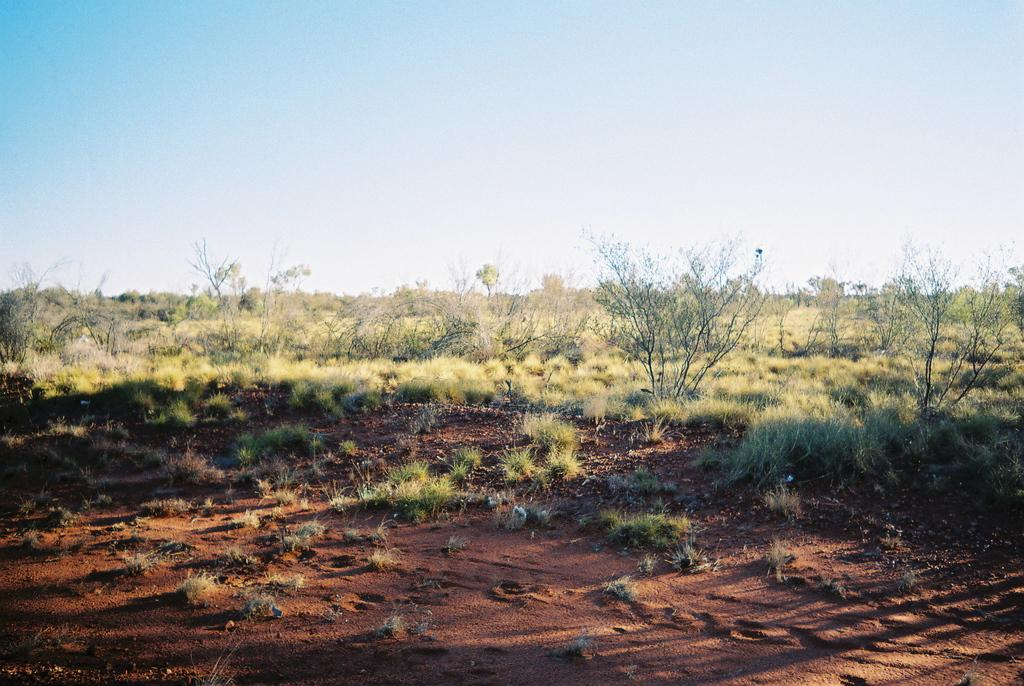What type of surface is visible in the center of the image? There is grass on the ground in the center of the image. What other natural elements can be seen in the image? There are plants in the image. What type of plastic material is covering the plants in the image? There is no plastic material covering the plants in the image; the plants are not obscured or altered in any way. 